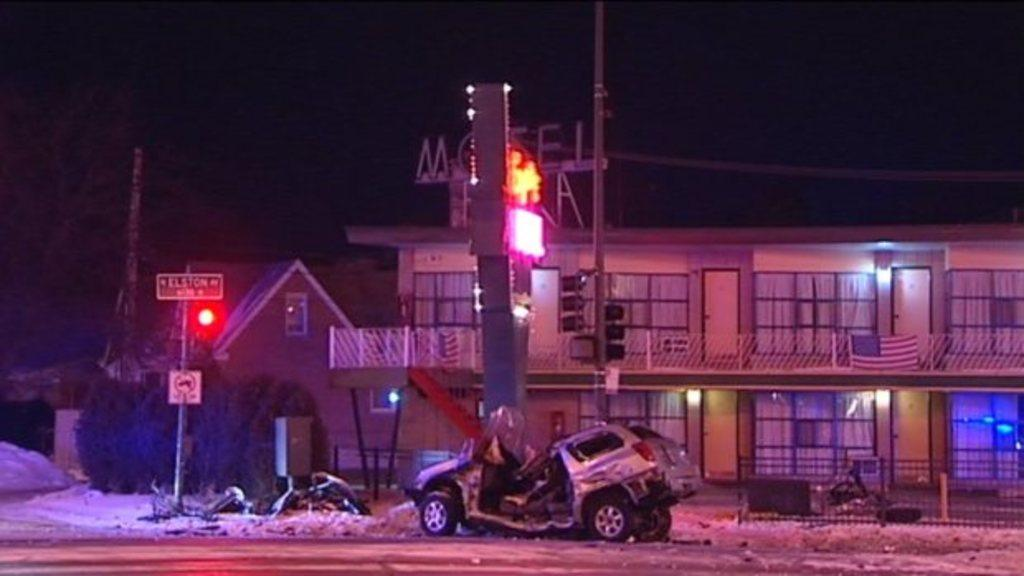What is the main subject of the image? The main subject of the image is a crashed car. What else can be seen in the image besides the crashed car? There is a road, a traffic signal, houses, plants, and a dark sky visible in the background of the image. Can you describe the road in the image? The road is visible in the image, but its condition or any specific features are not mentioned in the facts. What is the condition of the sky in the image? The sky is dark in the background of the image. What type of food is being prepared on the boats in the image? There are no boats or food preparation visible in the image. What message of peace can be seen in the image? There is no message of peace or any reference to peace in the image. 